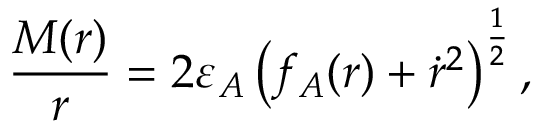<formula> <loc_0><loc_0><loc_500><loc_500>\frac { M ( r ) } { r } = 2 \varepsilon _ { A } \left ( f _ { A } ( r ) + \dot { r } ^ { 2 } \right ) ^ { \frac { 1 } { 2 } } ,</formula> 